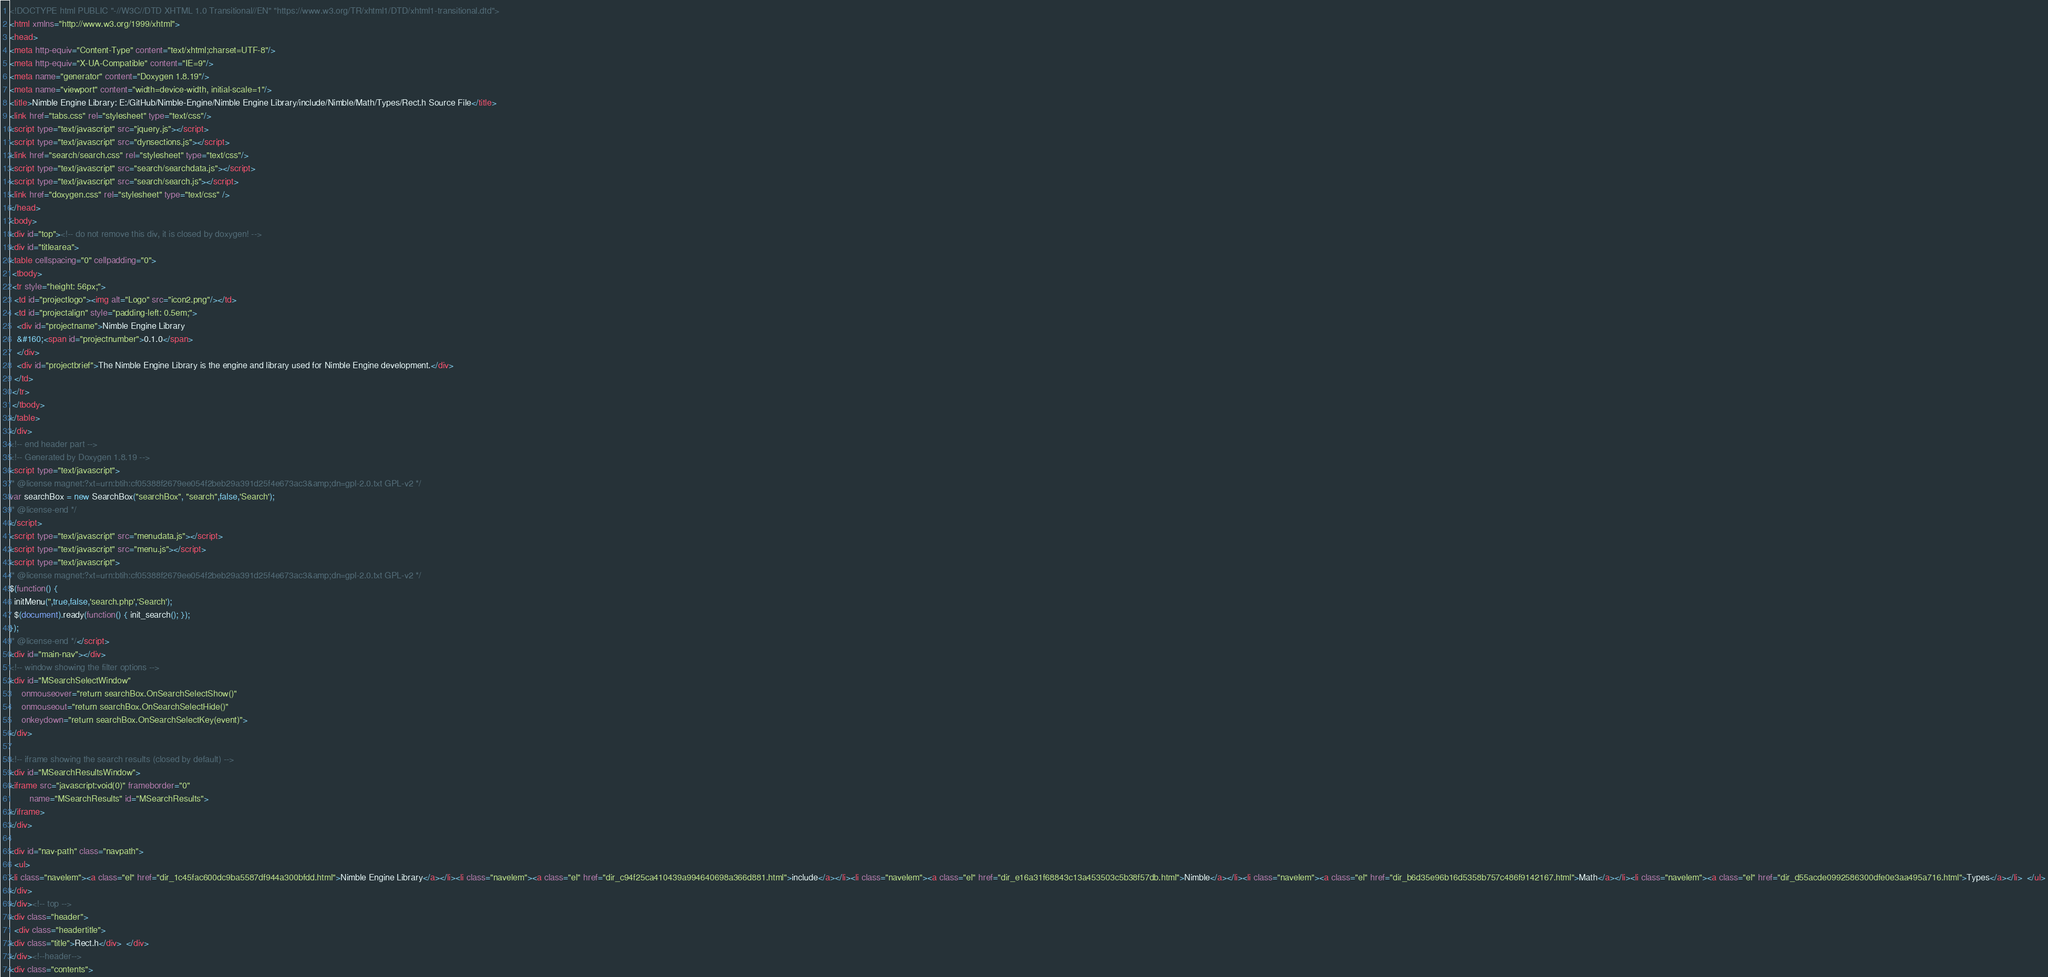Convert code to text. <code><loc_0><loc_0><loc_500><loc_500><_HTML_><!DOCTYPE html PUBLIC "-//W3C//DTD XHTML 1.0 Transitional//EN" "https://www.w3.org/TR/xhtml1/DTD/xhtml1-transitional.dtd">
<html xmlns="http://www.w3.org/1999/xhtml">
<head>
<meta http-equiv="Content-Type" content="text/xhtml;charset=UTF-8"/>
<meta http-equiv="X-UA-Compatible" content="IE=9"/>
<meta name="generator" content="Doxygen 1.8.19"/>
<meta name="viewport" content="width=device-width, initial-scale=1"/>
<title>Nimble Engine Library: E:/GitHub/Nimble-Engine/Nimble Engine Library/include/Nimble/Math/Types/Rect.h Source File</title>
<link href="tabs.css" rel="stylesheet" type="text/css"/>
<script type="text/javascript" src="jquery.js"></script>
<script type="text/javascript" src="dynsections.js"></script>
<link href="search/search.css" rel="stylesheet" type="text/css"/>
<script type="text/javascript" src="search/searchdata.js"></script>
<script type="text/javascript" src="search/search.js"></script>
<link href="doxygen.css" rel="stylesheet" type="text/css" />
</head>
<body>
<div id="top"><!-- do not remove this div, it is closed by doxygen! -->
<div id="titlearea">
<table cellspacing="0" cellpadding="0">
 <tbody>
 <tr style="height: 56px;">
  <td id="projectlogo"><img alt="Logo" src="icon2.png"/></td>
  <td id="projectalign" style="padding-left: 0.5em;">
   <div id="projectname">Nimble Engine Library
   &#160;<span id="projectnumber">0.1.0</span>
   </div>
   <div id="projectbrief">The Nimble Engine Library is the engine and library used for Nimble Engine development.</div>
  </td>
 </tr>
 </tbody>
</table>
</div>
<!-- end header part -->
<!-- Generated by Doxygen 1.8.19 -->
<script type="text/javascript">
/* @license magnet:?xt=urn:btih:cf05388f2679ee054f2beb29a391d25f4e673ac3&amp;dn=gpl-2.0.txt GPL-v2 */
var searchBox = new SearchBox("searchBox", "search",false,'Search');
/* @license-end */
</script>
<script type="text/javascript" src="menudata.js"></script>
<script type="text/javascript" src="menu.js"></script>
<script type="text/javascript">
/* @license magnet:?xt=urn:btih:cf05388f2679ee054f2beb29a391d25f4e673ac3&amp;dn=gpl-2.0.txt GPL-v2 */
$(function() {
  initMenu('',true,false,'search.php','Search');
  $(document).ready(function() { init_search(); });
});
/* @license-end */</script>
<div id="main-nav"></div>
<!-- window showing the filter options -->
<div id="MSearchSelectWindow"
     onmouseover="return searchBox.OnSearchSelectShow()"
     onmouseout="return searchBox.OnSearchSelectHide()"
     onkeydown="return searchBox.OnSearchSelectKey(event)">
</div>

<!-- iframe showing the search results (closed by default) -->
<div id="MSearchResultsWindow">
<iframe src="javascript:void(0)" frameborder="0" 
        name="MSearchResults" id="MSearchResults">
</iframe>
</div>

<div id="nav-path" class="navpath">
  <ul>
<li class="navelem"><a class="el" href="dir_1c45fac600dc9ba5587df944a300bfdd.html">Nimble Engine Library</a></li><li class="navelem"><a class="el" href="dir_c94f25ca410439a994640698a366d881.html">include</a></li><li class="navelem"><a class="el" href="dir_e16a31f68843c13a453503c5b38f57db.html">Nimble</a></li><li class="navelem"><a class="el" href="dir_b6d35e96b16d5358b757c486f9142167.html">Math</a></li><li class="navelem"><a class="el" href="dir_d55acde0992586300dfe0e3aa495a716.html">Types</a></li>  </ul>
</div>
</div><!-- top -->
<div class="header">
  <div class="headertitle">
<div class="title">Rect.h</div>  </div>
</div><!--header-->
<div class="contents"></code> 